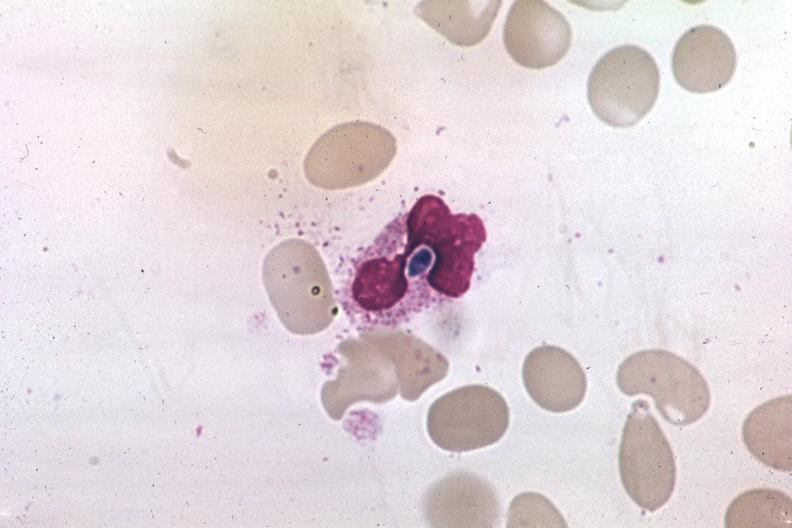what is present?
Answer the question using a single word or phrase. Hematologic 